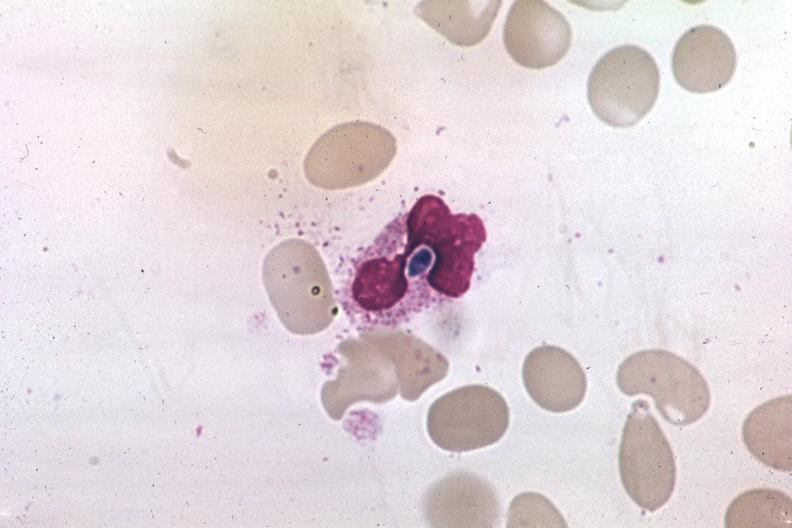what is present?
Answer the question using a single word or phrase. Hematologic 